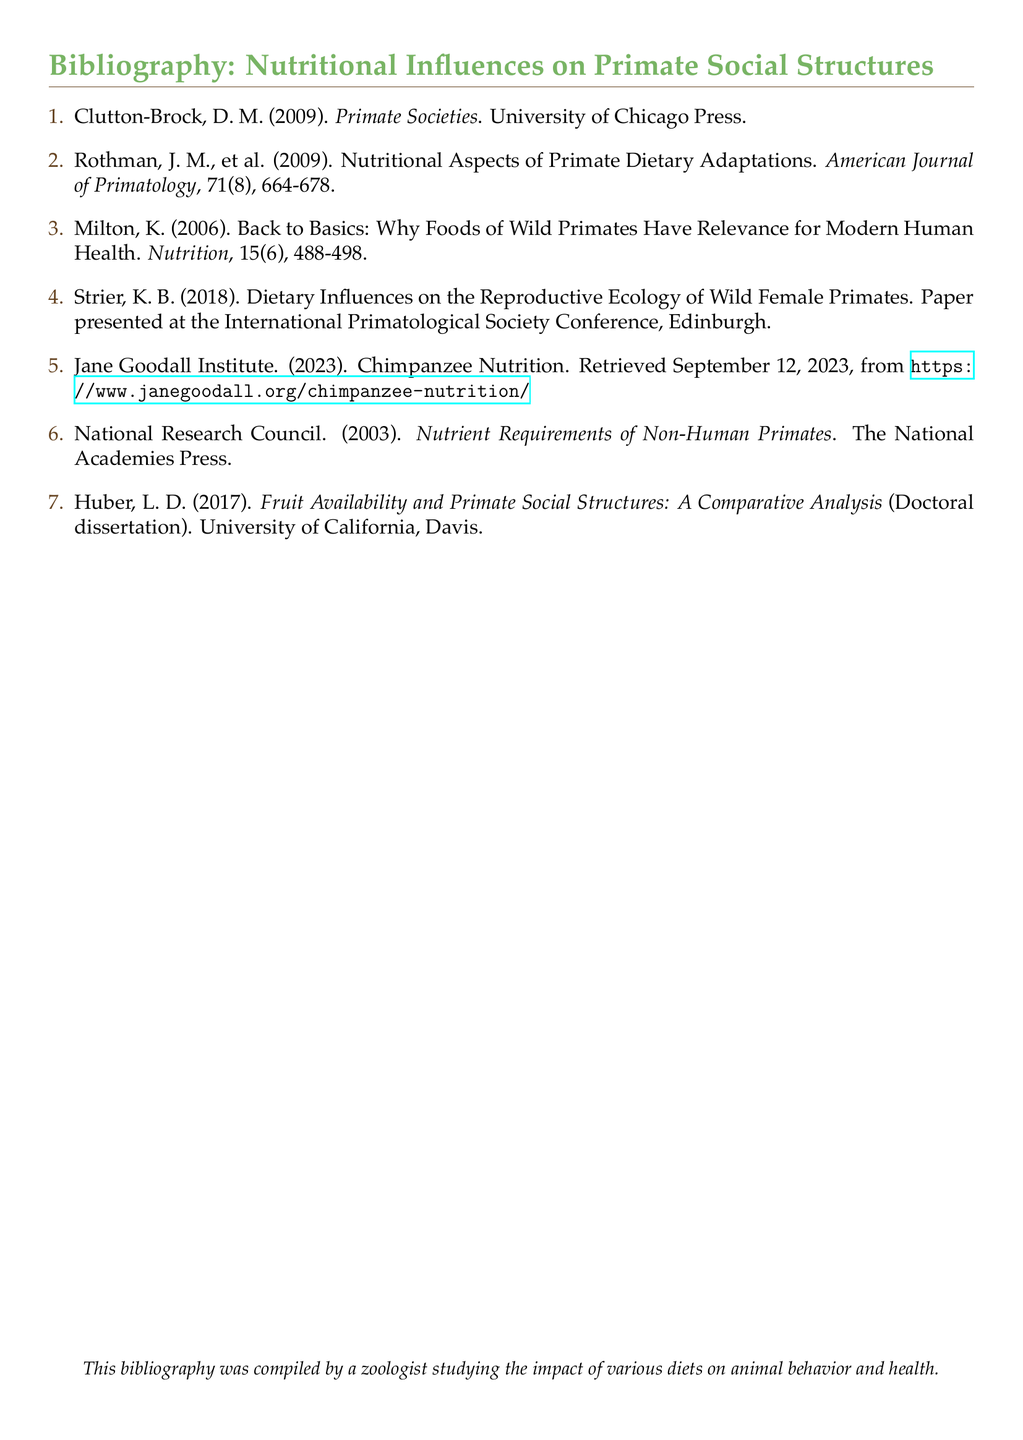what is the first item in the bibliography? The first item is listed with the author's name and title, which is 'Clutton-Brock, D. M. (2009). Primate Societies.'
Answer: Clutton-Brock, D. M. (2009). Primate Societies how many articles are listed in the bibliography? There are a total of seven items listed in the bibliography.
Answer: 7 who presented a paper at the International Primatological Society Conference? The document states that 'Strier, K. B. (2018)' presented a paper, indicating her involvement.
Answer: Strier, K. B. (2018) what is the focus of Rothman et al.'s article? The title indicates it covers 'Nutritional Aspects of Primate Dietary Adaptations', providing insights into diet-related adaptations.
Answer: Nutritional Aspects of Primate Dietary Adaptations which publication discusses the nutrient requirements of non-human primates? The item titled 'National Research Council. (2003). Nutrient Requirements of Non-Human Primates' directly addresses this topic.
Answer: Nutrient Requirements of Non-Human Primates when was the Jane Goodall Institute's information on chimpanzee nutrition retrieved? The document states that the information was retrieved on 'September 12, 2023'.
Answer: September 12, 2023 what type of document is Huber's work? The reference refers to Huber's work as a 'Doctoral dissertation', indicating its nature.
Answer: Doctoral dissertation which university is associated with Huber's research? The document references the University of California, Davis, as the institution linked to Huber's research.
Answer: University of California, Davis 